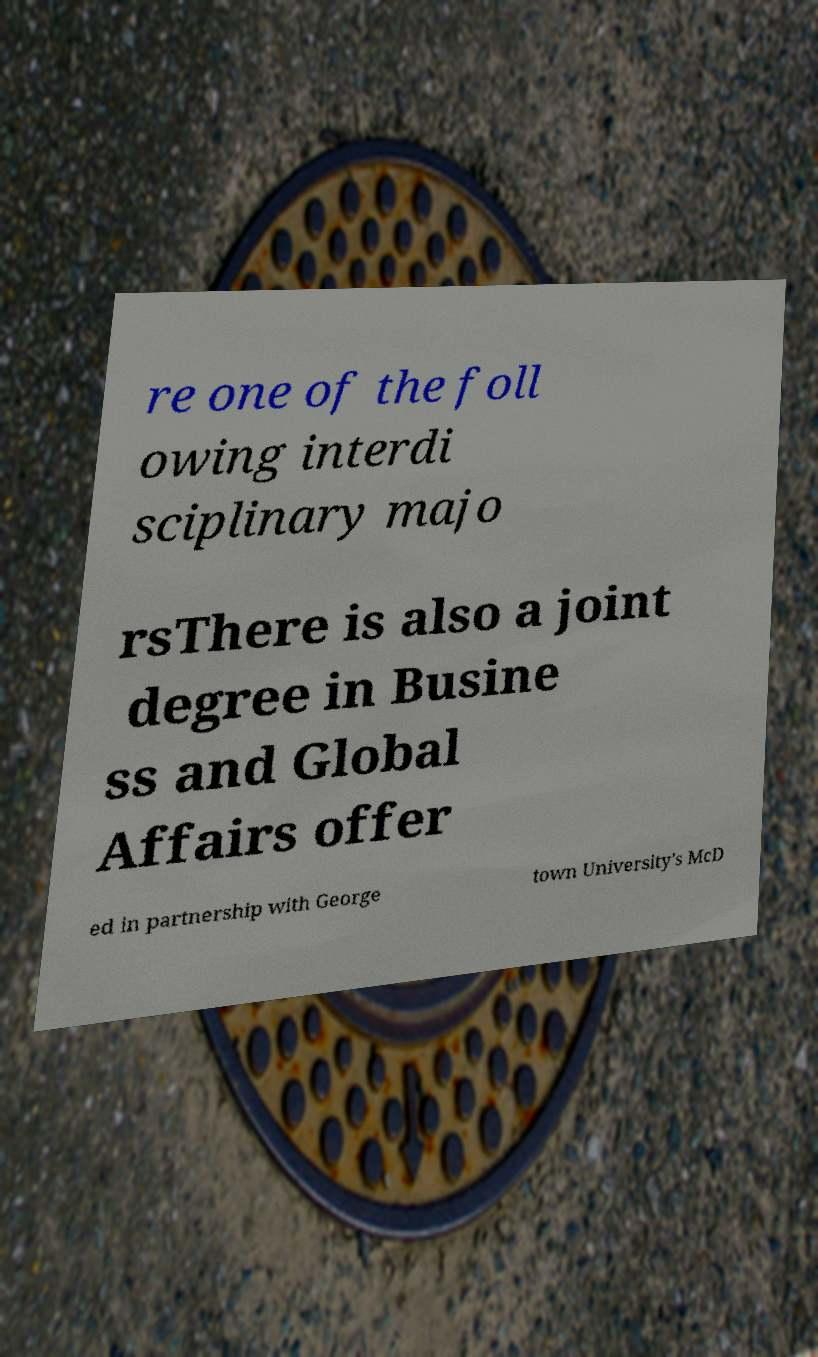Could you assist in decoding the text presented in this image and type it out clearly? re one of the foll owing interdi sciplinary majo rsThere is also a joint degree in Busine ss and Global Affairs offer ed in partnership with George town University's McD 